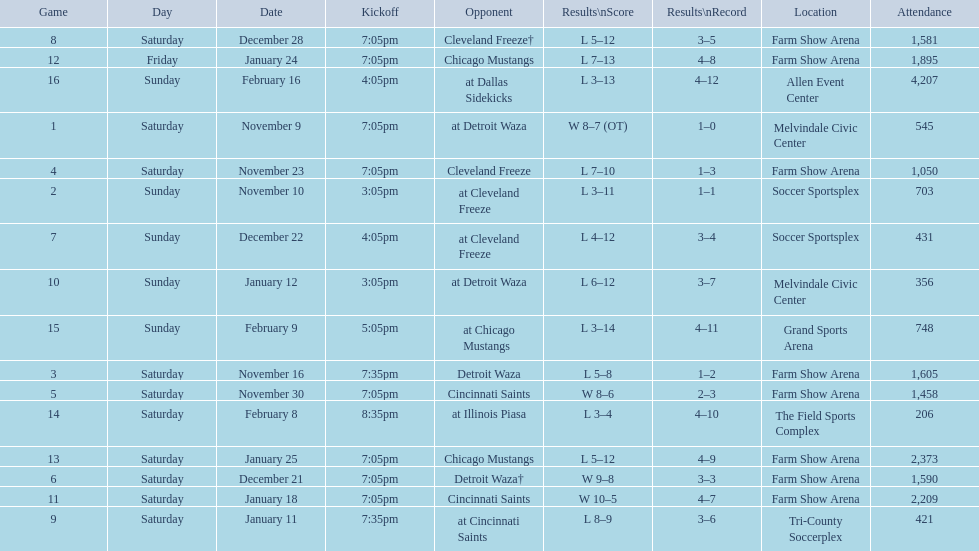What was the location before tri-county soccerplex? Farm Show Arena. 